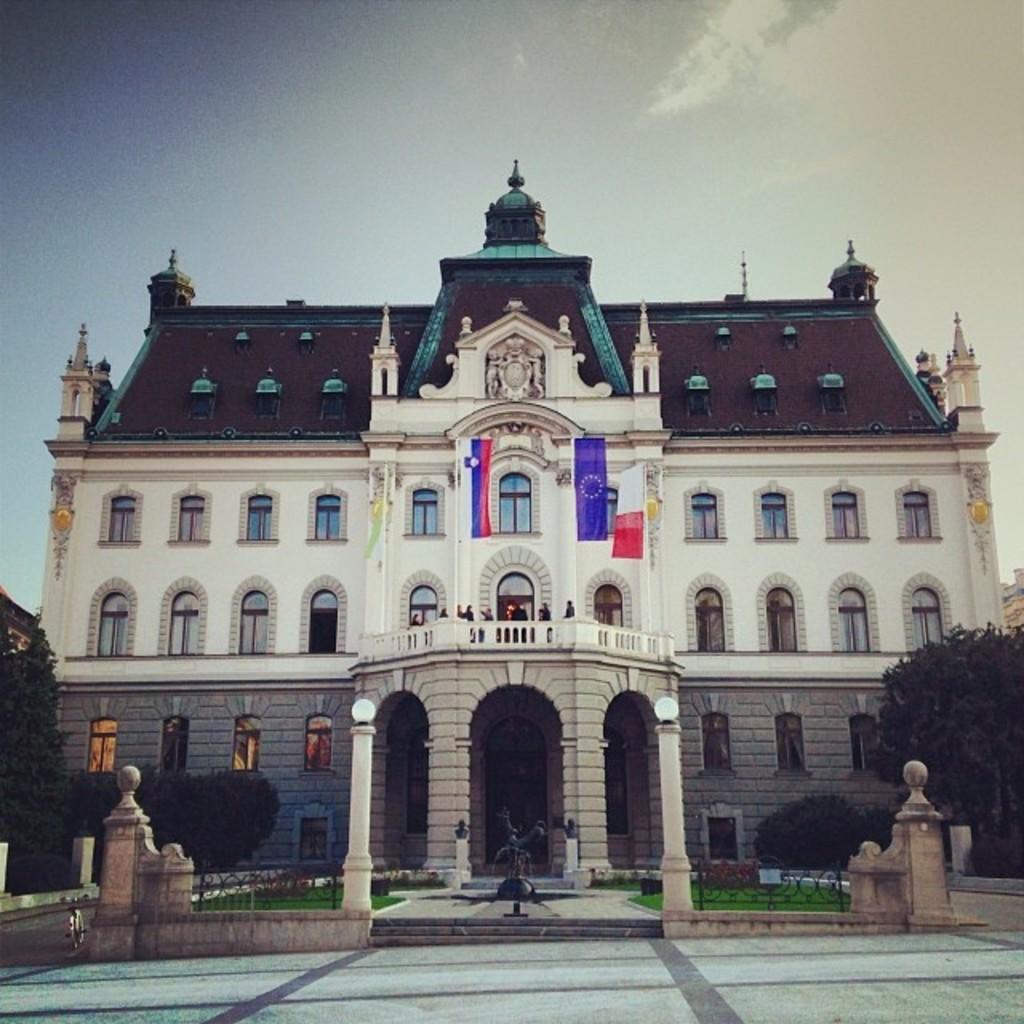Can you describe this image briefly? In this picture we can see the ground, grass, statue, trees, flags, building with windows, some objects and in the background we can see the sky. 